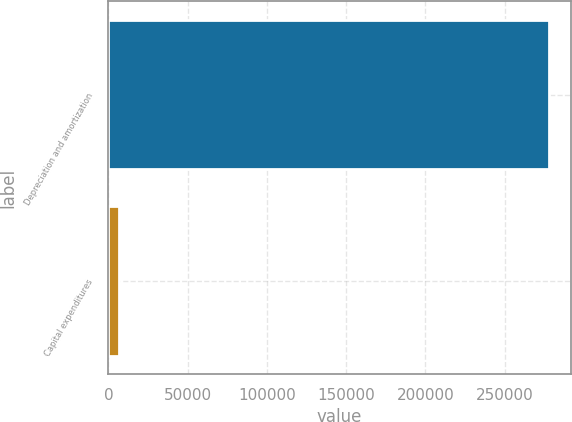<chart> <loc_0><loc_0><loc_500><loc_500><bar_chart><fcel>Depreciation and amortization<fcel>Capital expenditures<nl><fcel>277691<fcel>6951<nl></chart> 